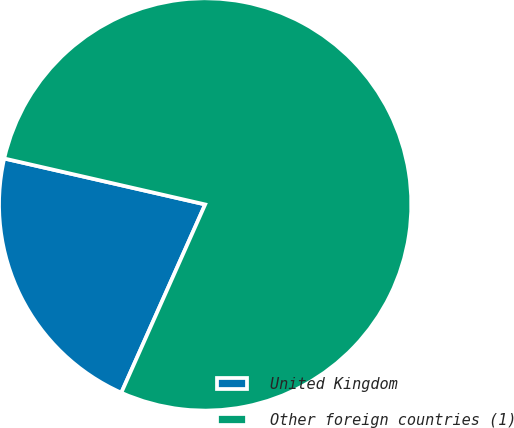Convert chart. <chart><loc_0><loc_0><loc_500><loc_500><pie_chart><fcel>United Kingdom<fcel>Other foreign countries (1)<nl><fcel>21.91%<fcel>78.09%<nl></chart> 